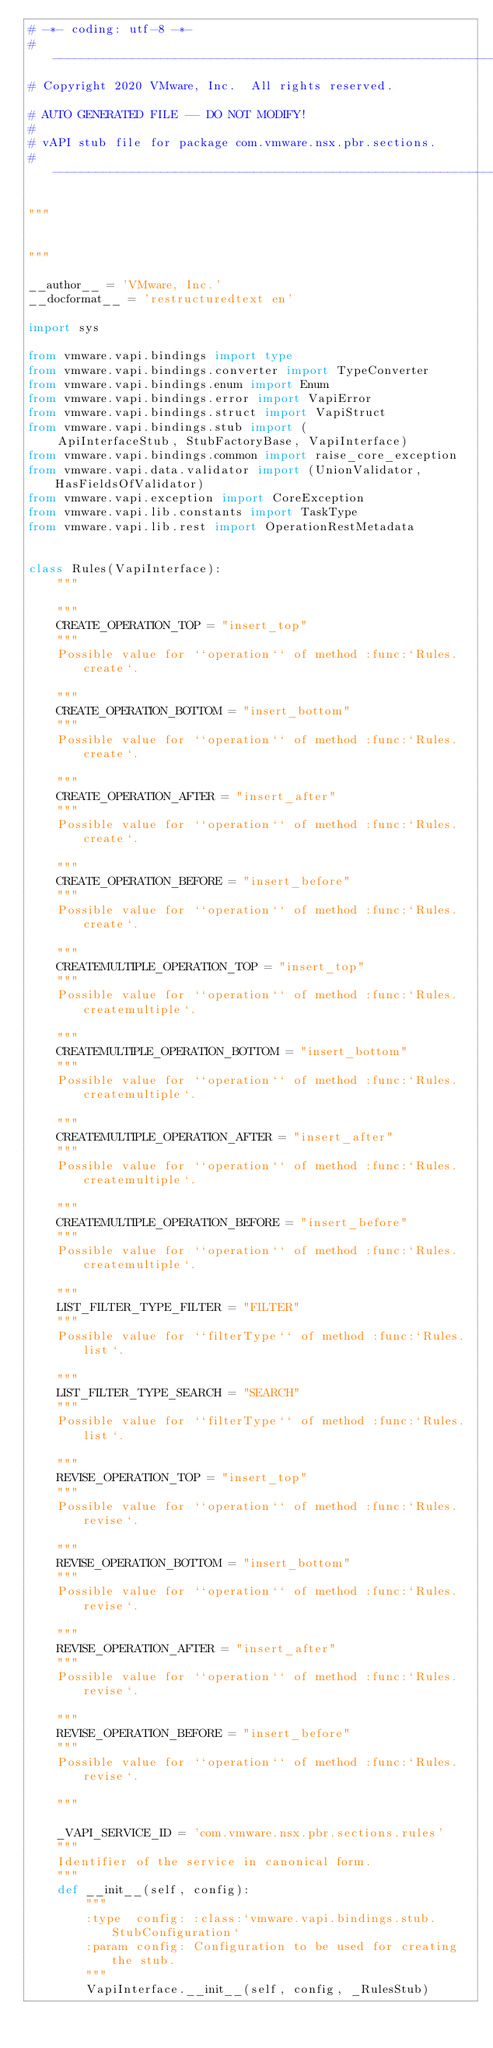<code> <loc_0><loc_0><loc_500><loc_500><_Python_># -*- coding: utf-8 -*-
#---------------------------------------------------------------------------
# Copyright 2020 VMware, Inc.  All rights reserved.

# AUTO GENERATED FILE -- DO NOT MODIFY!
#
# vAPI stub file for package com.vmware.nsx.pbr.sections.
#---------------------------------------------------------------------------

"""


"""

__author__ = 'VMware, Inc.'
__docformat__ = 'restructuredtext en'

import sys

from vmware.vapi.bindings import type
from vmware.vapi.bindings.converter import TypeConverter
from vmware.vapi.bindings.enum import Enum
from vmware.vapi.bindings.error import VapiError
from vmware.vapi.bindings.struct import VapiStruct
from vmware.vapi.bindings.stub import (
    ApiInterfaceStub, StubFactoryBase, VapiInterface)
from vmware.vapi.bindings.common import raise_core_exception
from vmware.vapi.data.validator import (UnionValidator, HasFieldsOfValidator)
from vmware.vapi.exception import CoreException
from vmware.vapi.lib.constants import TaskType
from vmware.vapi.lib.rest import OperationRestMetadata


class Rules(VapiInterface):
    """
    
    """
    CREATE_OPERATION_TOP = "insert_top"
    """
    Possible value for ``operation`` of method :func:`Rules.create`.

    """
    CREATE_OPERATION_BOTTOM = "insert_bottom"
    """
    Possible value for ``operation`` of method :func:`Rules.create`.

    """
    CREATE_OPERATION_AFTER = "insert_after"
    """
    Possible value for ``operation`` of method :func:`Rules.create`.

    """
    CREATE_OPERATION_BEFORE = "insert_before"
    """
    Possible value for ``operation`` of method :func:`Rules.create`.

    """
    CREATEMULTIPLE_OPERATION_TOP = "insert_top"
    """
    Possible value for ``operation`` of method :func:`Rules.createmultiple`.

    """
    CREATEMULTIPLE_OPERATION_BOTTOM = "insert_bottom"
    """
    Possible value for ``operation`` of method :func:`Rules.createmultiple`.

    """
    CREATEMULTIPLE_OPERATION_AFTER = "insert_after"
    """
    Possible value for ``operation`` of method :func:`Rules.createmultiple`.

    """
    CREATEMULTIPLE_OPERATION_BEFORE = "insert_before"
    """
    Possible value for ``operation`` of method :func:`Rules.createmultiple`.

    """
    LIST_FILTER_TYPE_FILTER = "FILTER"
    """
    Possible value for ``filterType`` of method :func:`Rules.list`.

    """
    LIST_FILTER_TYPE_SEARCH = "SEARCH"
    """
    Possible value for ``filterType`` of method :func:`Rules.list`.

    """
    REVISE_OPERATION_TOP = "insert_top"
    """
    Possible value for ``operation`` of method :func:`Rules.revise`.

    """
    REVISE_OPERATION_BOTTOM = "insert_bottom"
    """
    Possible value for ``operation`` of method :func:`Rules.revise`.

    """
    REVISE_OPERATION_AFTER = "insert_after"
    """
    Possible value for ``operation`` of method :func:`Rules.revise`.

    """
    REVISE_OPERATION_BEFORE = "insert_before"
    """
    Possible value for ``operation`` of method :func:`Rules.revise`.

    """

    _VAPI_SERVICE_ID = 'com.vmware.nsx.pbr.sections.rules'
    """
    Identifier of the service in canonical form.
    """
    def __init__(self, config):
        """
        :type  config: :class:`vmware.vapi.bindings.stub.StubConfiguration`
        :param config: Configuration to be used for creating the stub.
        """
        VapiInterface.__init__(self, config, _RulesStub)</code> 